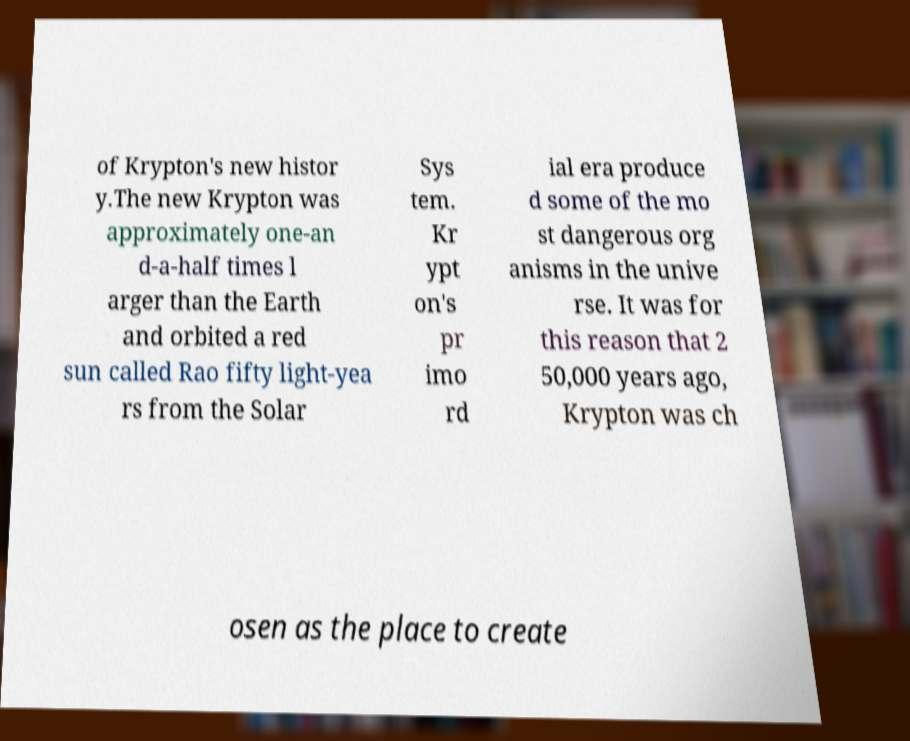Could you extract and type out the text from this image? of Krypton's new histor y.The new Krypton was approximately one-an d-a-half times l arger than the Earth and orbited a red sun called Rao fifty light-yea rs from the Solar Sys tem. Kr ypt on's pr imo rd ial era produce d some of the mo st dangerous org anisms in the unive rse. It was for this reason that 2 50,000 years ago, Krypton was ch osen as the place to create 